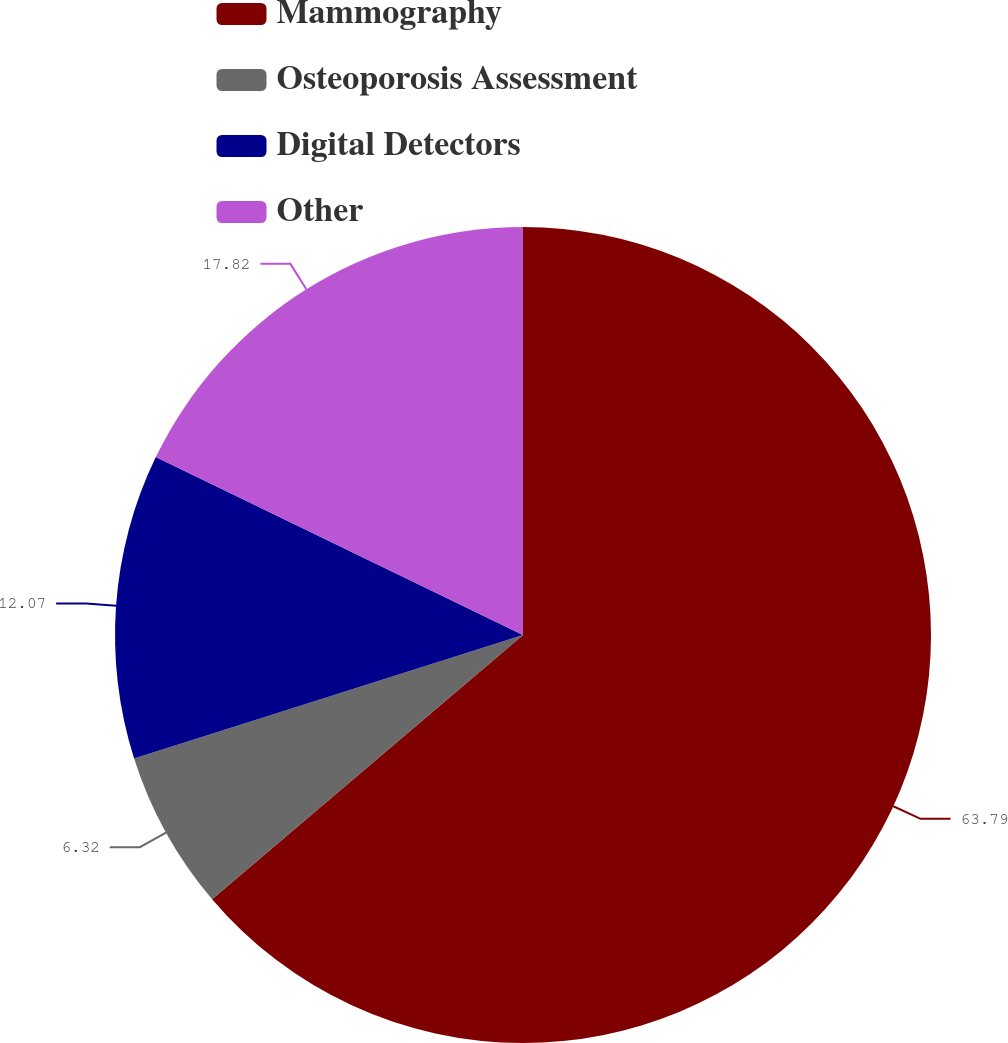Convert chart to OTSL. <chart><loc_0><loc_0><loc_500><loc_500><pie_chart><fcel>Mammography<fcel>Osteoporosis Assessment<fcel>Digital Detectors<fcel>Other<nl><fcel>63.79%<fcel>6.32%<fcel>12.07%<fcel>17.82%<nl></chart> 